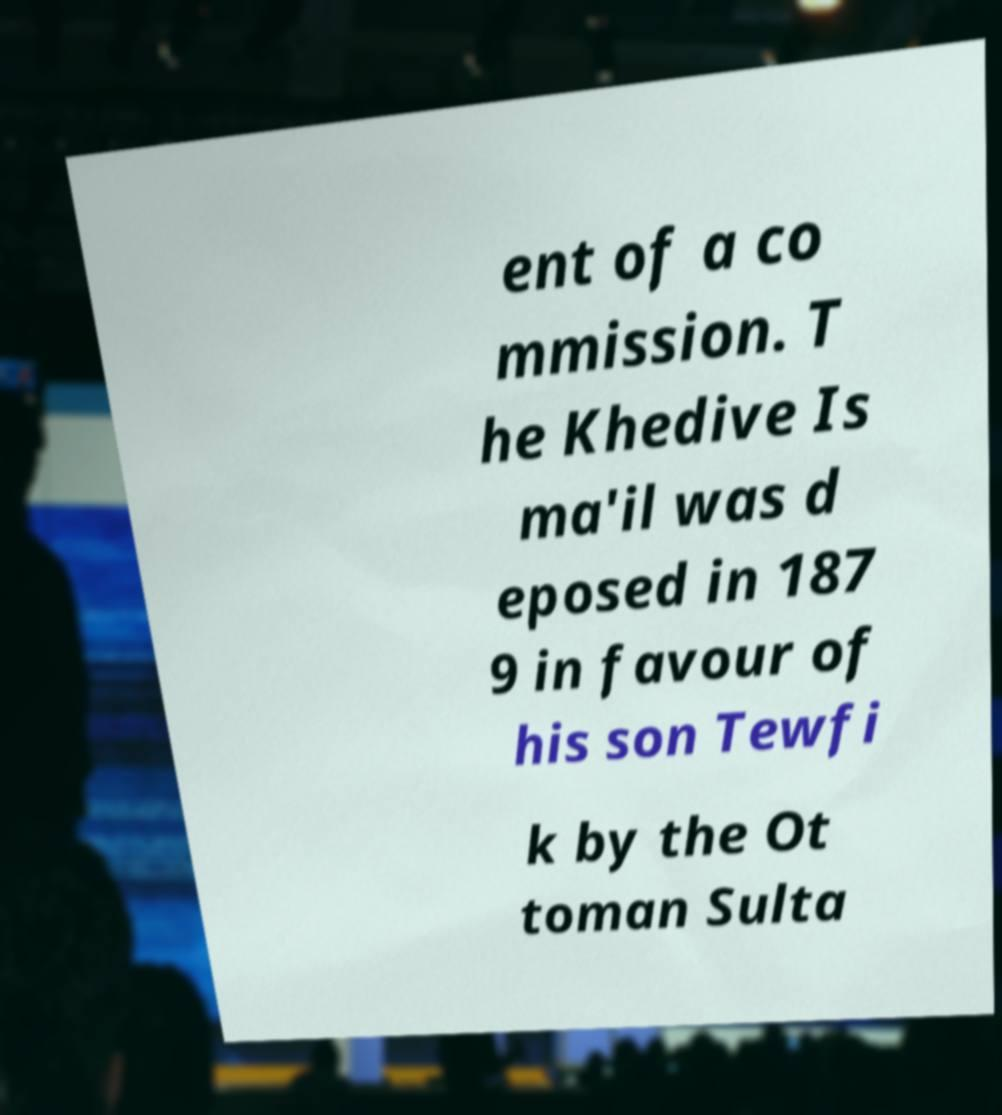There's text embedded in this image that I need extracted. Can you transcribe it verbatim? ent of a co mmission. T he Khedive Is ma'il was d eposed in 187 9 in favour of his son Tewfi k by the Ot toman Sulta 